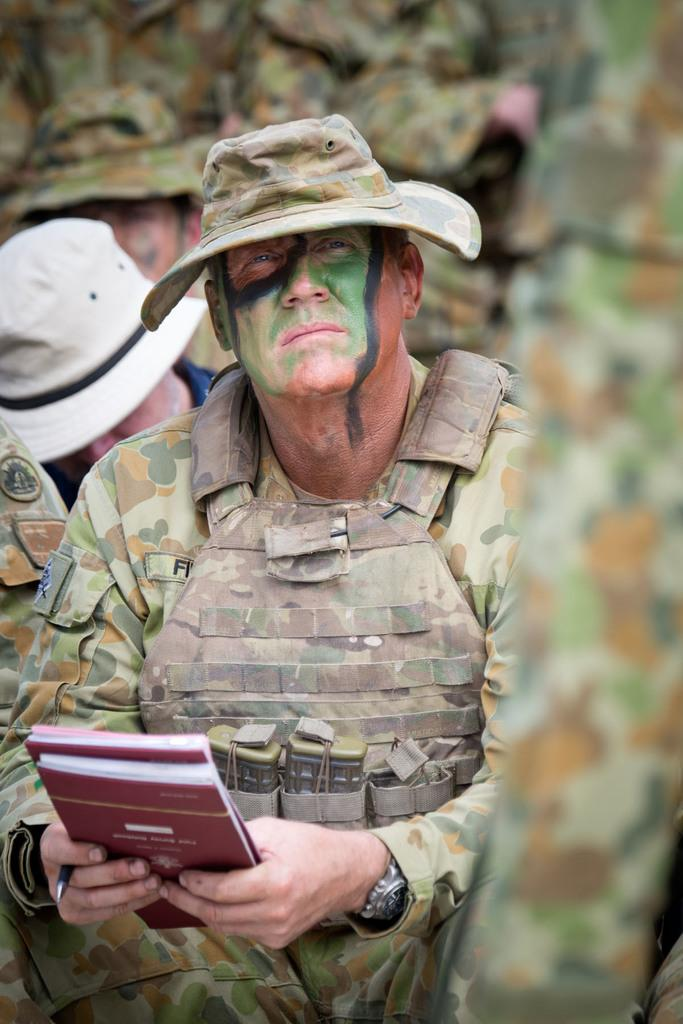What is the person in the image doing? The person is sitting and holding books. What else is the person holding in the image? The person is also holding a pen. Can you describe the background of the image? There are men visible in the background of the image. Where is the shelf located in the image? There is no shelf present in the image. What type of riddle can be solved by looking at the person in the image? There is no riddle present in the image, and the person's actions do not suggest a riddle. 